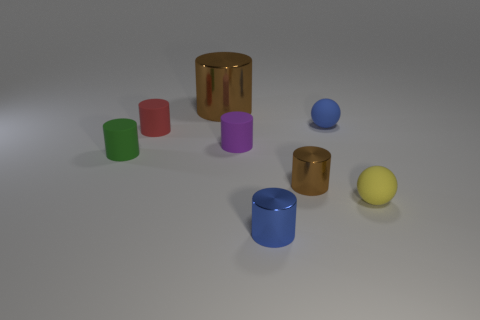Subtract all small purple cylinders. How many cylinders are left? 5 Subtract all green cylinders. How many cylinders are left? 5 Subtract all gray cylinders. Subtract all purple balls. How many cylinders are left? 6 Add 1 purple rubber cylinders. How many objects exist? 9 Subtract all cylinders. How many objects are left? 2 Add 8 red rubber balls. How many red rubber balls exist? 8 Subtract 0 purple cubes. How many objects are left? 8 Subtract all tiny gray rubber balls. Subtract all green rubber cylinders. How many objects are left? 7 Add 5 purple rubber cylinders. How many purple rubber cylinders are left? 6 